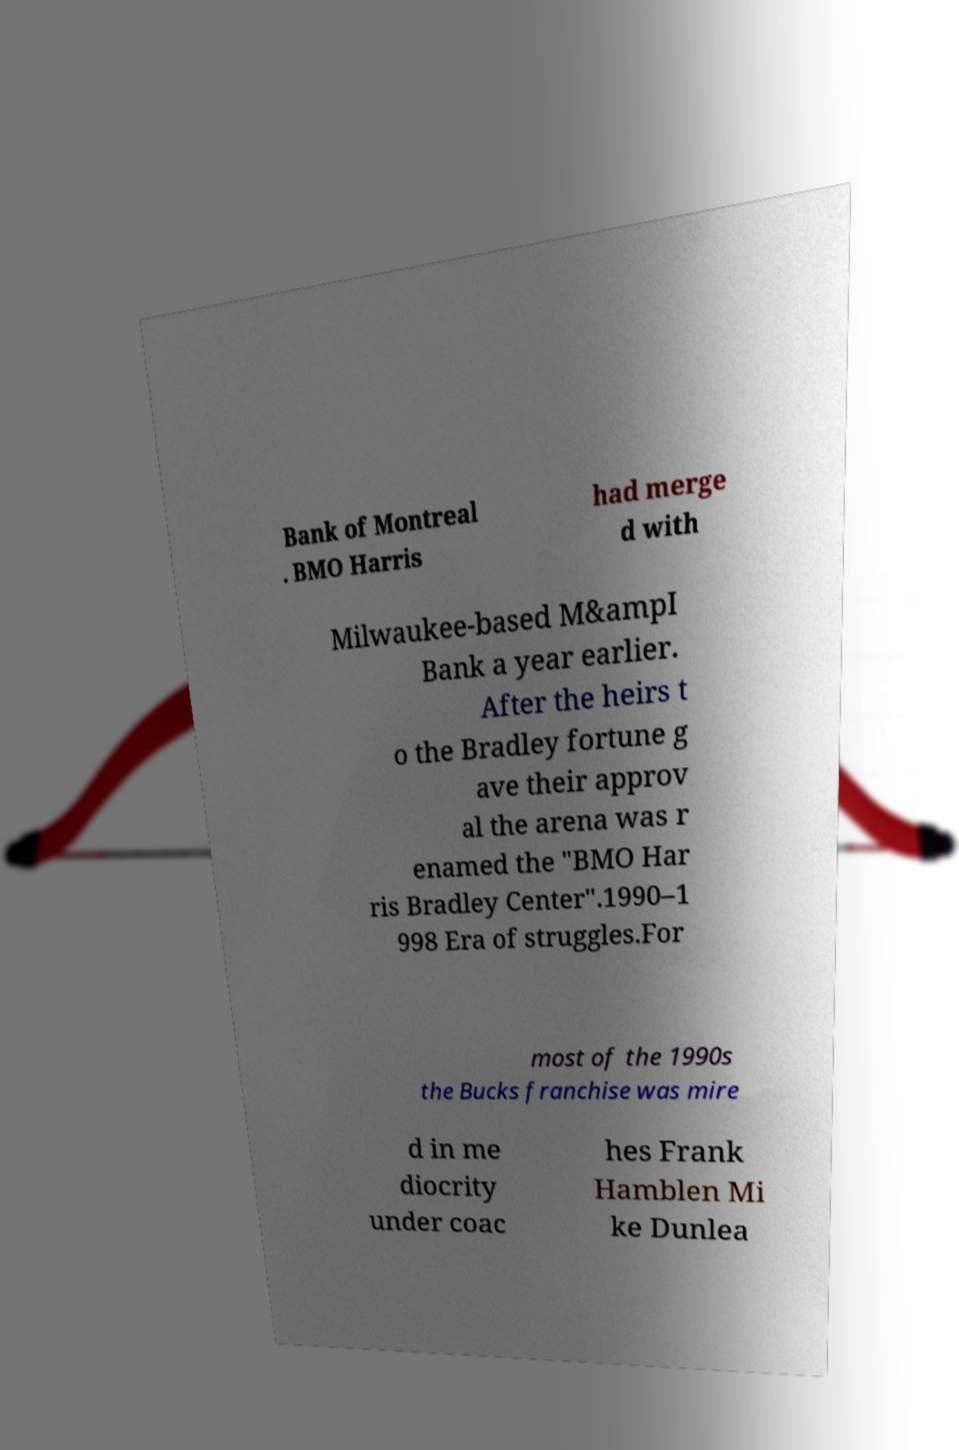Could you assist in decoding the text presented in this image and type it out clearly? Bank of Montreal . BMO Harris had merge d with Milwaukee-based M&ampI Bank a year earlier. After the heirs t o the Bradley fortune g ave their approv al the arena was r enamed the "BMO Har ris Bradley Center".1990–1 998 Era of struggles.For most of the 1990s the Bucks franchise was mire d in me diocrity under coac hes Frank Hamblen Mi ke Dunlea 